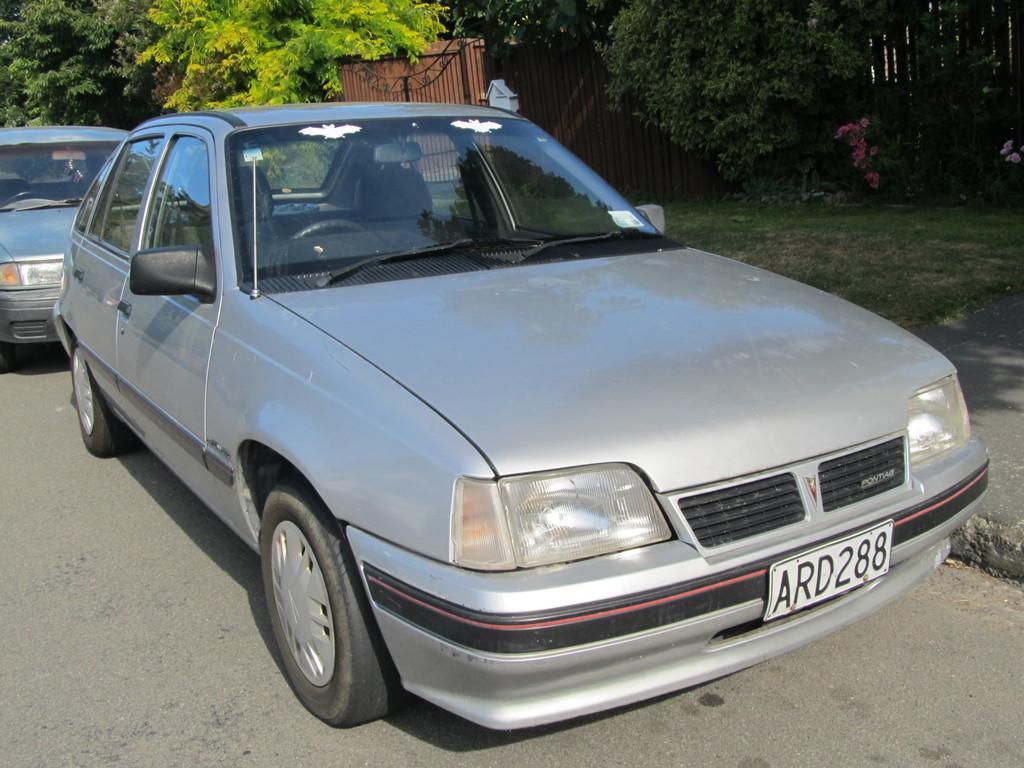Please provide a concise description of this image. This image is clicked outside. There are cars in the middle. They are of gray color. There are trees at the top. There is a gate at the top. 